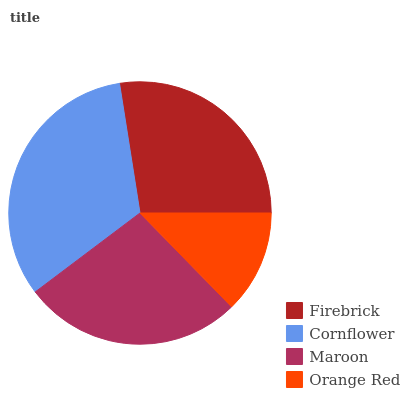Is Orange Red the minimum?
Answer yes or no. Yes. Is Cornflower the maximum?
Answer yes or no. Yes. Is Maroon the minimum?
Answer yes or no. No. Is Maroon the maximum?
Answer yes or no. No. Is Cornflower greater than Maroon?
Answer yes or no. Yes. Is Maroon less than Cornflower?
Answer yes or no. Yes. Is Maroon greater than Cornflower?
Answer yes or no. No. Is Cornflower less than Maroon?
Answer yes or no. No. Is Firebrick the high median?
Answer yes or no. Yes. Is Maroon the low median?
Answer yes or no. Yes. Is Maroon the high median?
Answer yes or no. No. Is Cornflower the low median?
Answer yes or no. No. 